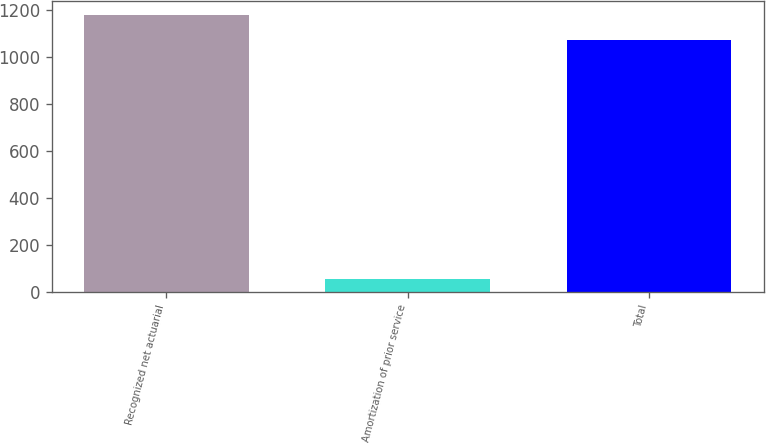Convert chart. <chart><loc_0><loc_0><loc_500><loc_500><bar_chart><fcel>Recognized net actuarial<fcel>Amortization of prior service<fcel>Total<nl><fcel>1179.2<fcel>56<fcel>1072<nl></chart> 